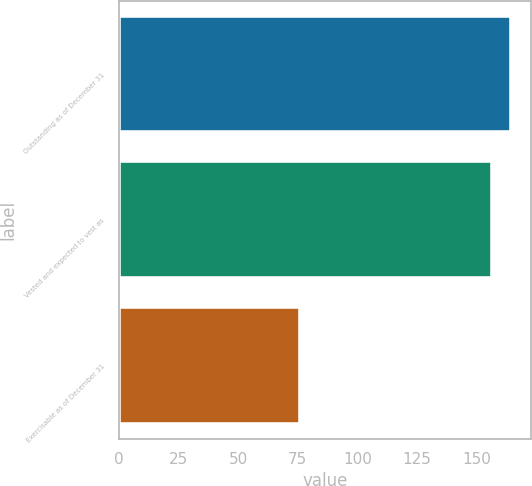<chart> <loc_0><loc_0><loc_500><loc_500><bar_chart><fcel>Outstanding as of December 31<fcel>Vested and expected to vest as<fcel>Exercisable as of December 31<nl><fcel>164.5<fcel>156.4<fcel>76.09<nl></chart> 